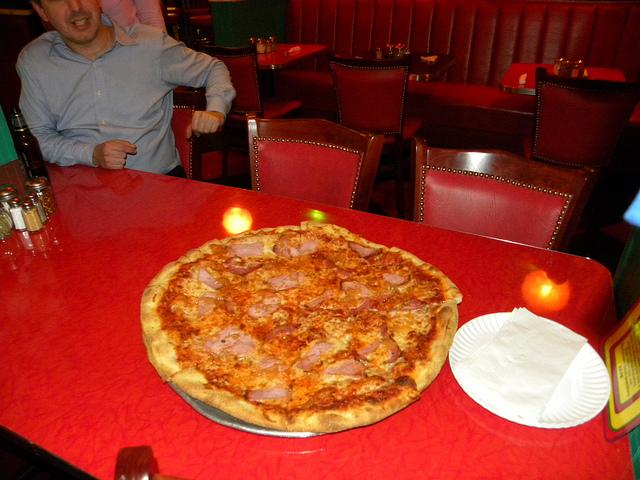What are the small candles on the table called? votives 